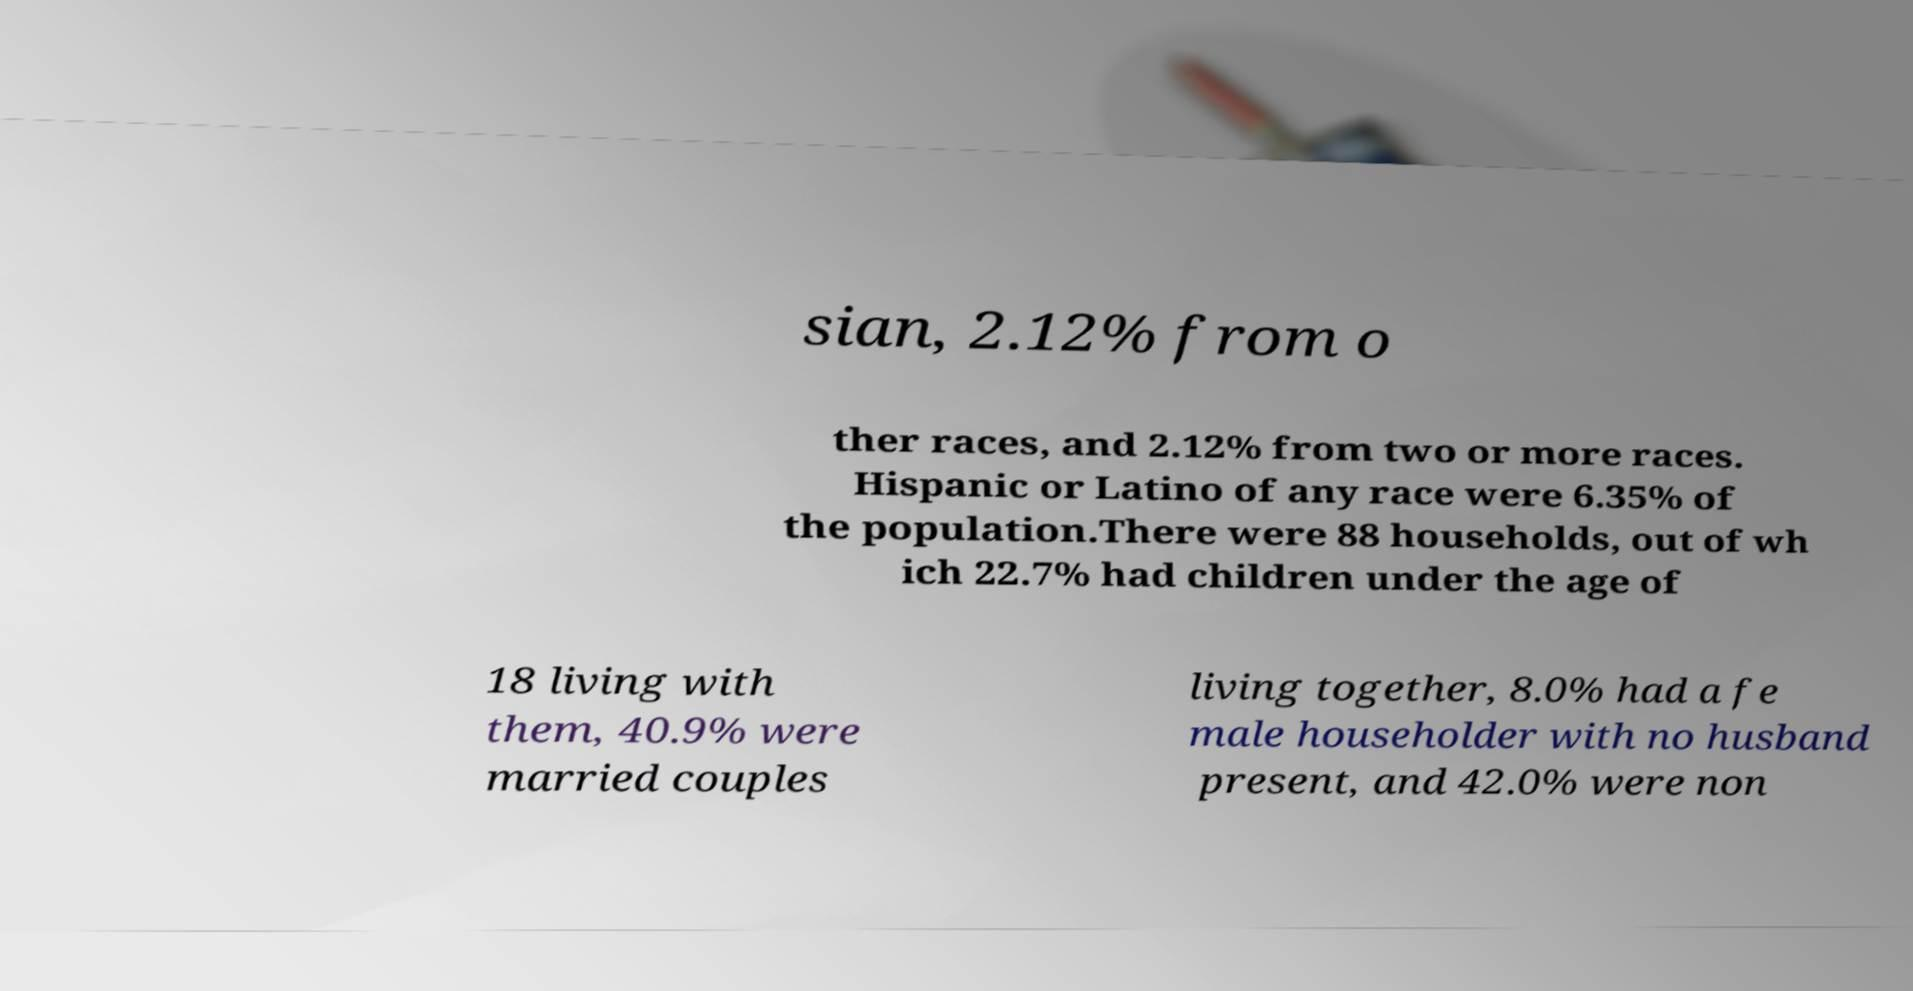Can you accurately transcribe the text from the provided image for me? sian, 2.12% from o ther races, and 2.12% from two or more races. Hispanic or Latino of any race were 6.35% of the population.There were 88 households, out of wh ich 22.7% had children under the age of 18 living with them, 40.9% were married couples living together, 8.0% had a fe male householder with no husband present, and 42.0% were non 